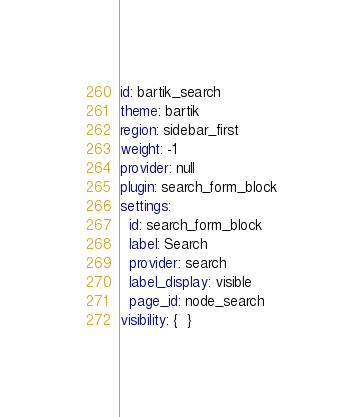Convert code to text. <code><loc_0><loc_0><loc_500><loc_500><_YAML_>id: bartik_search
theme: bartik
region: sidebar_first
weight: -1
provider: null
plugin: search_form_block
settings:
  id: search_form_block
  label: Search
  provider: search
  label_display: visible
  page_id: node_search
visibility: {  }
</code> 